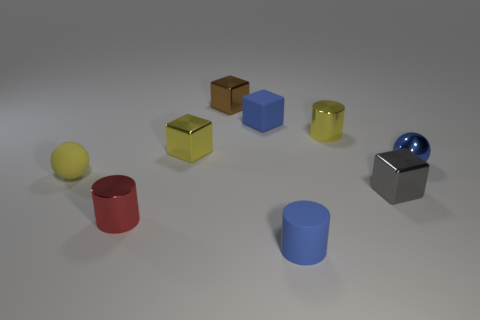How many other tiny objects are the same shape as the brown metal thing?
Provide a succinct answer. 3. Is the color of the cylinder behind the red metal object the same as the rubber block?
Your answer should be compact. No. There is a metal thing that is to the right of the small shiny block that is to the right of the blue matte block; what number of shiny objects are to the left of it?
Give a very brief answer. 5. How many small things are both on the left side of the yellow block and in front of the gray cube?
Offer a very short reply. 1. There is a tiny metallic thing that is the same color as the rubber cylinder; what is its shape?
Make the answer very short. Sphere. Is there any other thing that has the same material as the tiny gray block?
Provide a succinct answer. Yes. Do the small yellow sphere and the brown block have the same material?
Make the answer very short. No. There is a matte thing that is on the right side of the tiny matte object behind the metallic cylinder behind the small red cylinder; what is its shape?
Offer a very short reply. Cylinder. Is the number of small spheres to the left of the gray thing less than the number of cylinders that are on the left side of the small blue metal ball?
Your response must be concise. Yes. What is the shape of the small blue rubber thing that is in front of the shiny cylinder on the right side of the brown metallic cube?
Keep it short and to the point. Cylinder. 